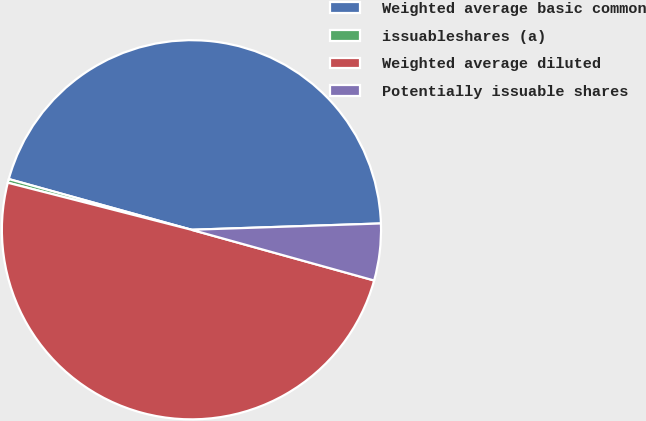Convert chart. <chart><loc_0><loc_0><loc_500><loc_500><pie_chart><fcel>Weighted average basic common<fcel>issuableshares (a)<fcel>Weighted average diluted<fcel>Potentially issuable shares<nl><fcel>45.16%<fcel>0.32%<fcel>49.68%<fcel>4.84%<nl></chart> 